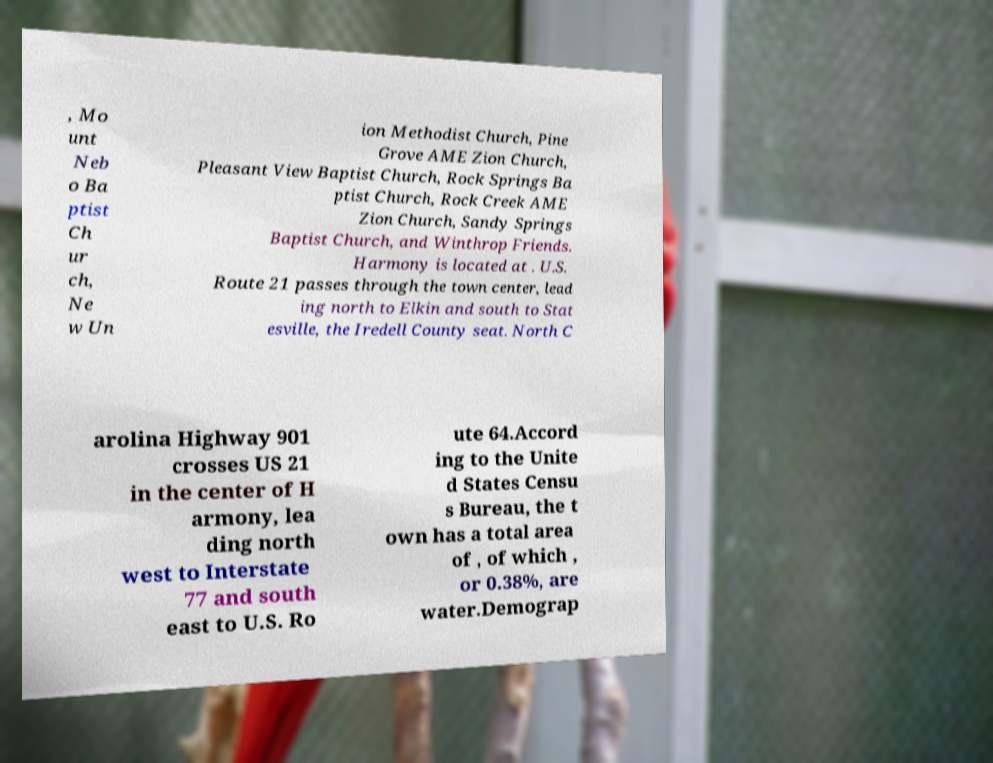For documentation purposes, I need the text within this image transcribed. Could you provide that? , Mo unt Neb o Ba ptist Ch ur ch, Ne w Un ion Methodist Church, Pine Grove AME Zion Church, Pleasant View Baptist Church, Rock Springs Ba ptist Church, Rock Creek AME Zion Church, Sandy Springs Baptist Church, and Winthrop Friends. Harmony is located at . U.S. Route 21 passes through the town center, lead ing north to Elkin and south to Stat esville, the Iredell County seat. North C arolina Highway 901 crosses US 21 in the center of H armony, lea ding north west to Interstate 77 and south east to U.S. Ro ute 64.Accord ing to the Unite d States Censu s Bureau, the t own has a total area of , of which , or 0.38%, are water.Demograp 